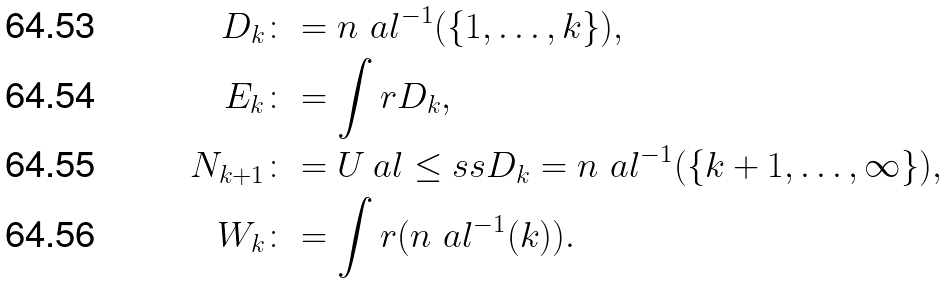<formula> <loc_0><loc_0><loc_500><loc_500>D _ { k } & \colon = n _ { \ } a l ^ { - 1 } ( \{ 1 , \dots , k \} ) , \\ E _ { k } & \colon = \int r D _ { k } , \\ N _ { k + 1 } & \colon = U _ { \ } a l \leq s s D _ { k } = n _ { \ } a l ^ { - 1 } ( \{ k + 1 , \dots , \infty \} ) , \\ W _ { k } & \colon = \int r ( n _ { \ } a l ^ { - 1 } ( k ) ) .</formula> 